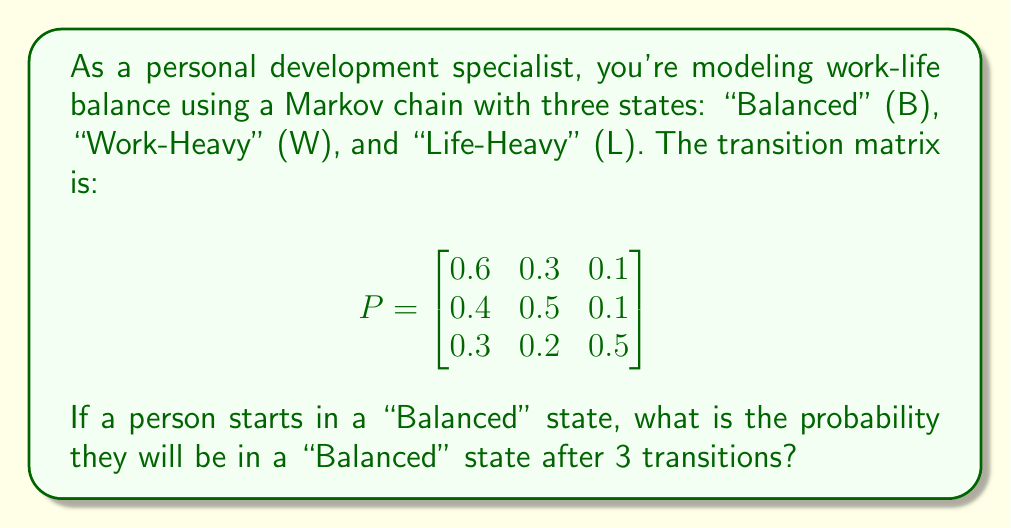Can you answer this question? To solve this problem, we need to follow these steps:

1) The initial state vector is $v_0 = [1, 0, 0]$ since the person starts in the "Balanced" state.

2) We need to calculate $v_0 P^3$, where $P^3$ is the transition matrix raised to the power of 3.

3) To calculate $P^3$, we multiply P by itself three times:

   $P^2 = P \times P = \begin{bmatrix}
   0.52 & 0.33 & 0.15 \\
   0.49 & 0.40 & 0.11 \\
   0.39 & 0.28 & 0.33
   \end{bmatrix}$

   $P^3 = P^2 \times P = \begin{bmatrix}
   0.499 & 0.339 & 0.162 \\
   0.490 & 0.355 & 0.155 \\
   0.451 & 0.314 & 0.235
   \end{bmatrix}$

4) Now, we multiply $v_0$ by $P^3$:

   $v_0 P^3 = [1, 0, 0] \times \begin{bmatrix}
   0.499 & 0.339 & 0.162 \\
   0.490 & 0.355 & 0.155 \\
   0.451 & 0.314 & 0.235
   \end{bmatrix} = [0.499, 0.339, 0.162]$

5) The probability of being in the "Balanced" state after 3 transitions is the first element of this resulting vector, which is 0.499 or approximately 0.5.
Answer: 0.499 